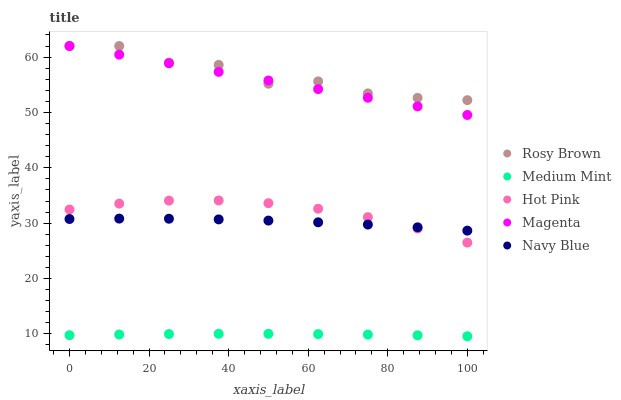Does Medium Mint have the minimum area under the curve?
Answer yes or no. Yes. Does Rosy Brown have the maximum area under the curve?
Answer yes or no. Yes. Does Navy Blue have the minimum area under the curve?
Answer yes or no. No. Does Navy Blue have the maximum area under the curve?
Answer yes or no. No. Is Magenta the smoothest?
Answer yes or no. Yes. Is Rosy Brown the roughest?
Answer yes or no. Yes. Is Navy Blue the smoothest?
Answer yes or no. No. Is Navy Blue the roughest?
Answer yes or no. No. Does Medium Mint have the lowest value?
Answer yes or no. Yes. Does Navy Blue have the lowest value?
Answer yes or no. No. Does Rosy Brown have the highest value?
Answer yes or no. Yes. Does Navy Blue have the highest value?
Answer yes or no. No. Is Navy Blue less than Magenta?
Answer yes or no. Yes. Is Rosy Brown greater than Medium Mint?
Answer yes or no. Yes. Does Rosy Brown intersect Magenta?
Answer yes or no. Yes. Is Rosy Brown less than Magenta?
Answer yes or no. No. Is Rosy Brown greater than Magenta?
Answer yes or no. No. Does Navy Blue intersect Magenta?
Answer yes or no. No. 